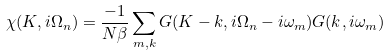<formula> <loc_0><loc_0><loc_500><loc_500>\chi ( { K } , i \Omega _ { n } ) = \frac { - 1 } { N \beta } \sum _ { m , { k } } G ( { K } - { k } , i \Omega _ { n } - i \omega _ { m } ) G ( { k } , i \omega _ { m } )</formula> 